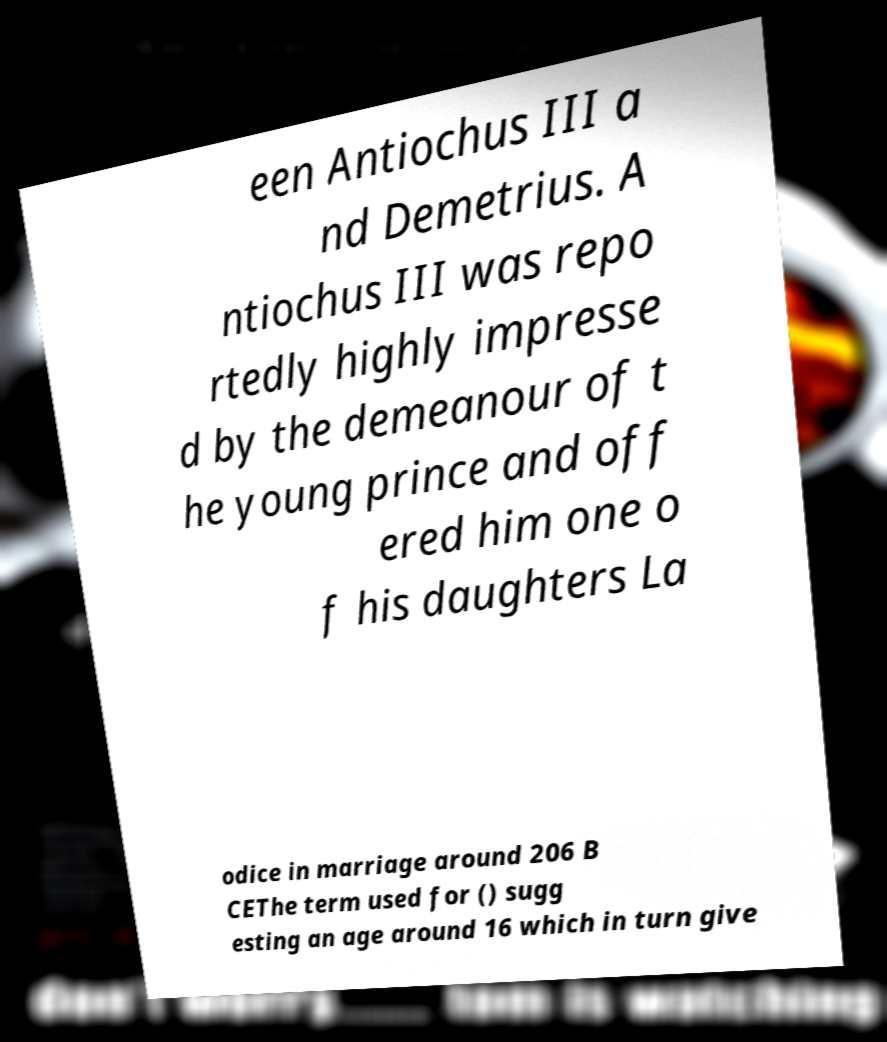Can you accurately transcribe the text from the provided image for me? een Antiochus III a nd Demetrius. A ntiochus III was repo rtedly highly impresse d by the demeanour of t he young prince and off ered him one o f his daughters La odice in marriage around 206 B CEThe term used for () sugg esting an age around 16 which in turn give 